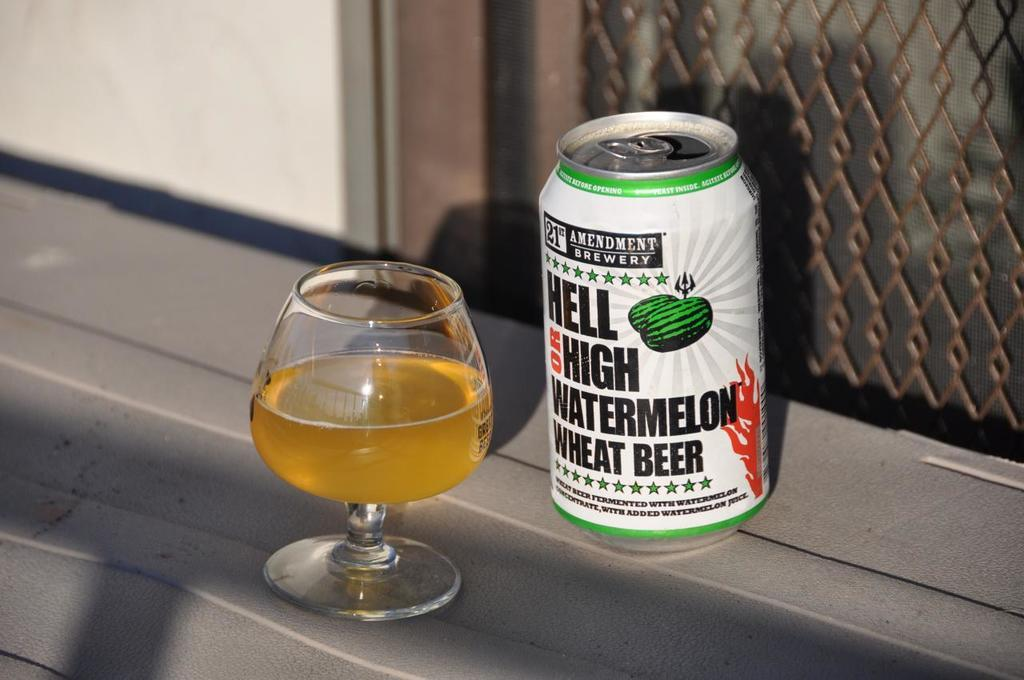<image>
Offer a succinct explanation of the picture presented. A can of watermelon wheat beer sits next to a stemmed glass. 